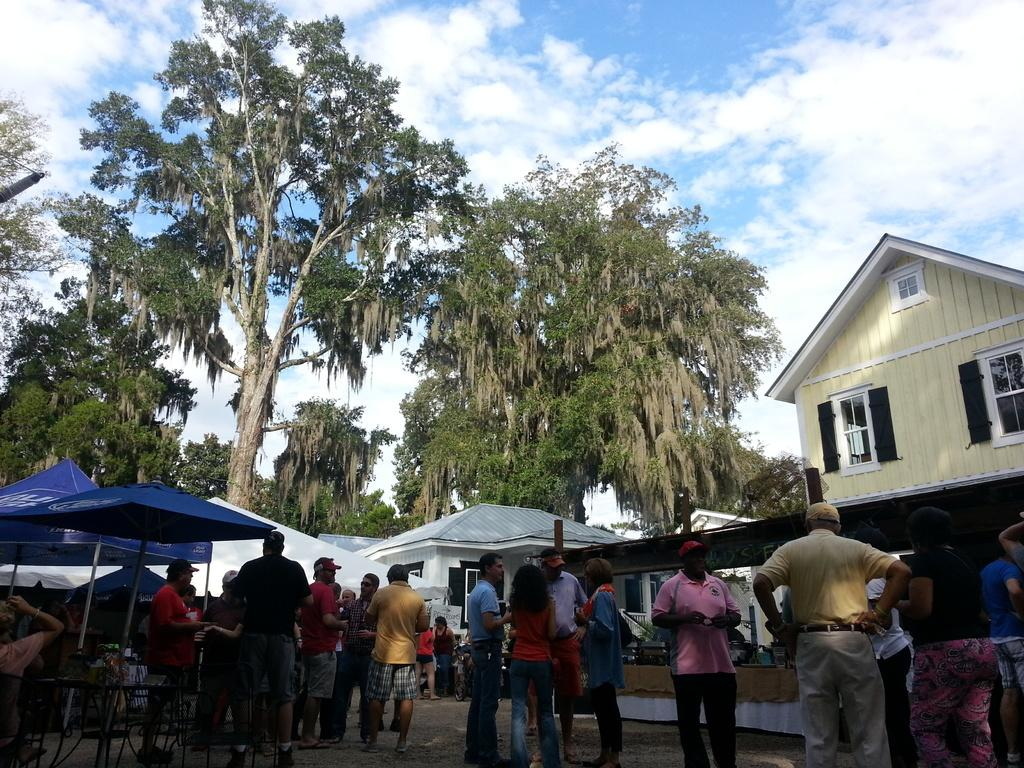What can be seen in the image related to people? There are people standing in the image. What type of structures are present in the image? There are tents, sheds, and a building in the image. What type of furniture is visible in the image? There are chairs and tables in the image. What type of natural elements can be seen in the image? There are trees in the image. What can be seen in the sky in the image? There are clouds in the sky. Can you hear the cracker being eaten in the image? There is no sound present in the image, and therefore no cracker being eaten can be heard. What type of boundary is visible in the image? There is no specific boundary mentioned in the image; it contains people, structures, furniture, trees, and clouds. 